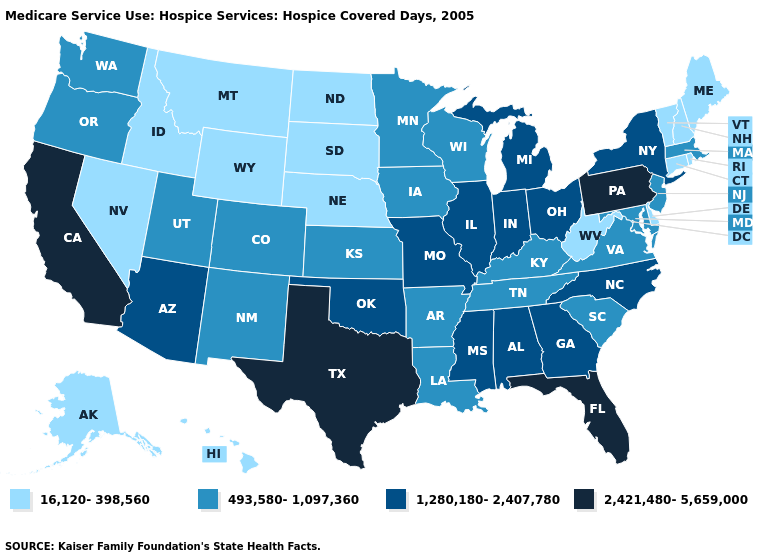Which states have the lowest value in the Northeast?
Write a very short answer. Connecticut, Maine, New Hampshire, Rhode Island, Vermont. What is the value of New York?
Write a very short answer. 1,280,180-2,407,780. Does the first symbol in the legend represent the smallest category?
Keep it brief. Yes. What is the value of Wisconsin?
Answer briefly. 493,580-1,097,360. How many symbols are there in the legend?
Short answer required. 4. Name the states that have a value in the range 1,280,180-2,407,780?
Keep it brief. Alabama, Arizona, Georgia, Illinois, Indiana, Michigan, Mississippi, Missouri, New York, North Carolina, Ohio, Oklahoma. Name the states that have a value in the range 16,120-398,560?
Write a very short answer. Alaska, Connecticut, Delaware, Hawaii, Idaho, Maine, Montana, Nebraska, Nevada, New Hampshire, North Dakota, Rhode Island, South Dakota, Vermont, West Virginia, Wyoming. Which states have the lowest value in the MidWest?
Give a very brief answer. Nebraska, North Dakota, South Dakota. What is the value of Florida?
Short answer required. 2,421,480-5,659,000. Does Louisiana have the lowest value in the USA?
Quick response, please. No. Does Nebraska have the highest value in the USA?
Concise answer only. No. Name the states that have a value in the range 493,580-1,097,360?
Short answer required. Arkansas, Colorado, Iowa, Kansas, Kentucky, Louisiana, Maryland, Massachusetts, Minnesota, New Jersey, New Mexico, Oregon, South Carolina, Tennessee, Utah, Virginia, Washington, Wisconsin. Does the first symbol in the legend represent the smallest category?
Concise answer only. Yes. Does the first symbol in the legend represent the smallest category?
Short answer required. Yes. Name the states that have a value in the range 2,421,480-5,659,000?
Answer briefly. California, Florida, Pennsylvania, Texas. 